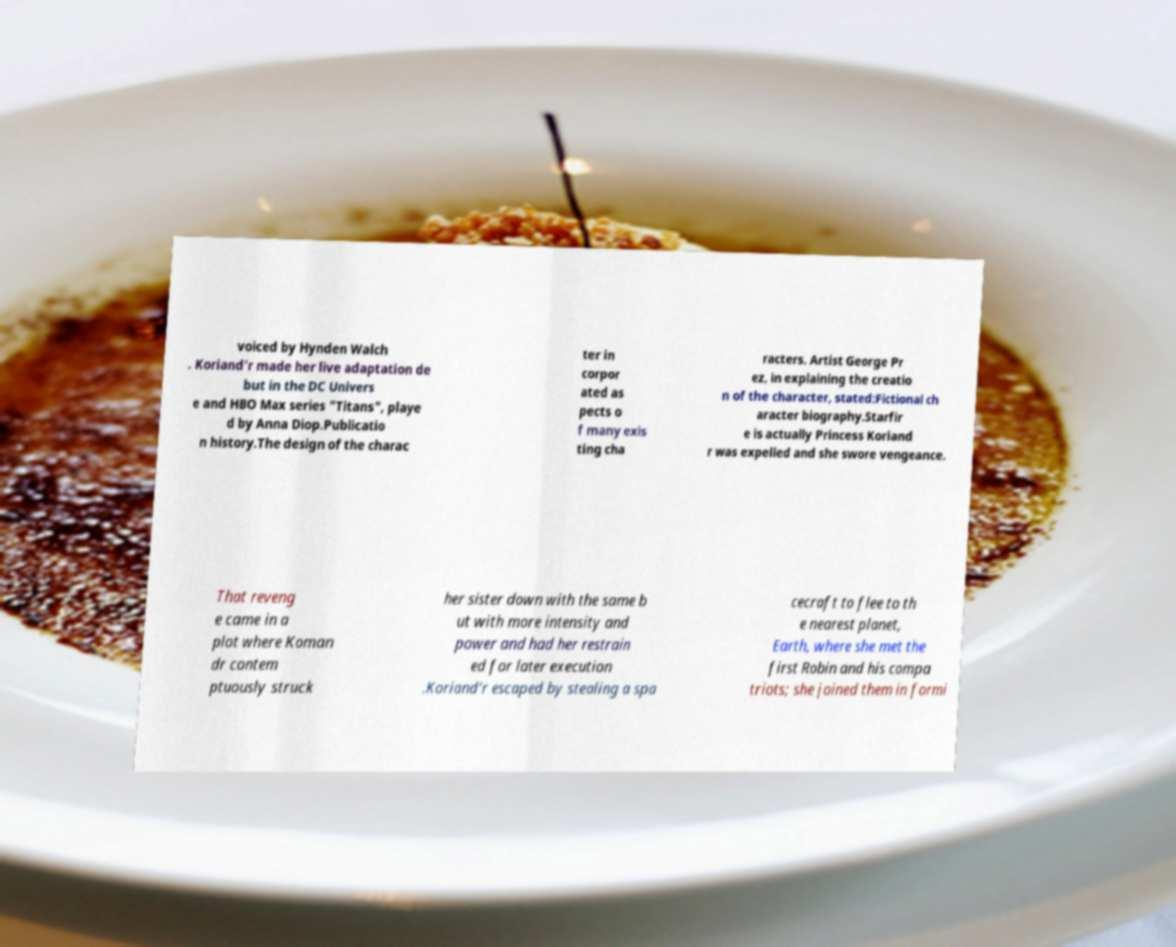Could you extract and type out the text from this image? voiced by Hynden Walch . Koriand'r made her live adaptation de but in the DC Univers e and HBO Max series "Titans", playe d by Anna Diop.Publicatio n history.The design of the charac ter in corpor ated as pects o f many exis ting cha racters. Artist George Pr ez, in explaining the creatio n of the character, stated:Fictional ch aracter biography.Starfir e is actually Princess Koriand r was expelled and she swore vengeance. That reveng e came in a plot where Koman dr contem ptuously struck her sister down with the same b ut with more intensity and power and had her restrain ed for later execution .Koriand'r escaped by stealing a spa cecraft to flee to th e nearest planet, Earth, where she met the first Robin and his compa triots; she joined them in formi 